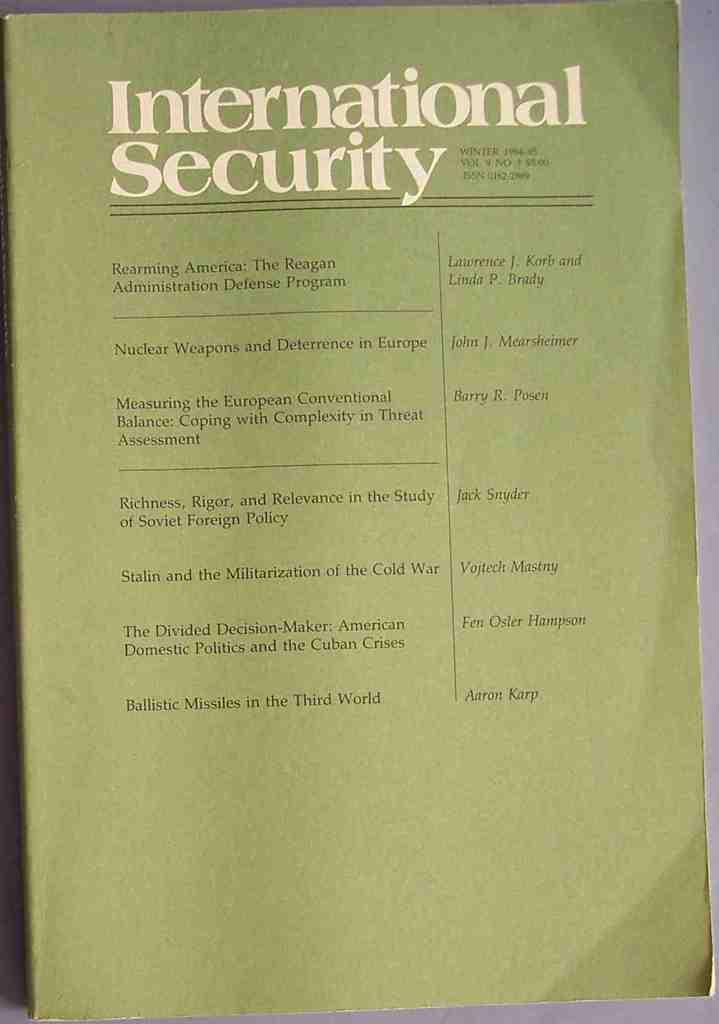<image>
Present a compact description of the photo's key features. a pamphlet that has International Security written on it 